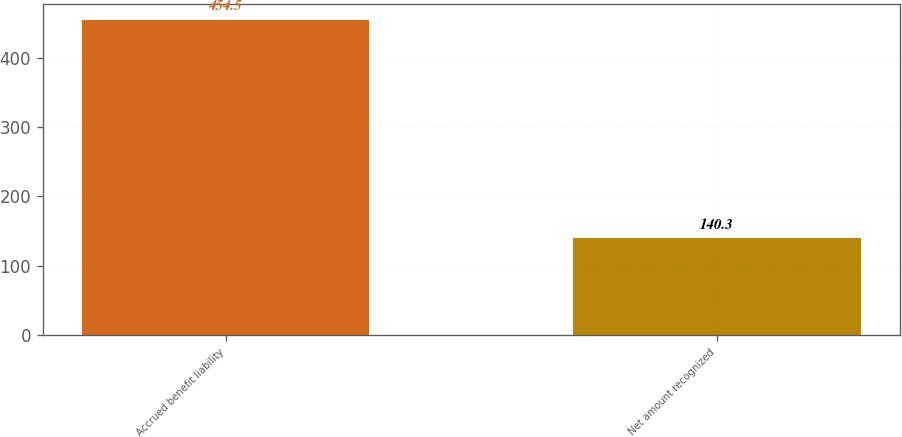Convert chart. <chart><loc_0><loc_0><loc_500><loc_500><bar_chart><fcel>Accrued benefit liability<fcel>Net amount recognized<nl><fcel>454.5<fcel>140.3<nl></chart> 